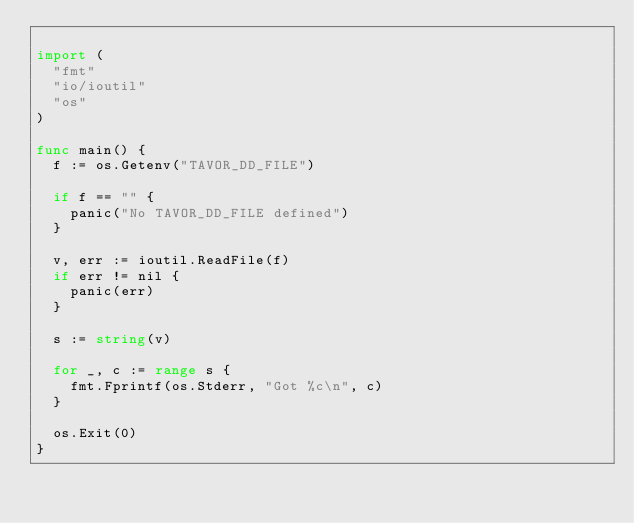<code> <loc_0><loc_0><loc_500><loc_500><_Go_>
import (
	"fmt"
	"io/ioutil"
	"os"
)

func main() {
	f := os.Getenv("TAVOR_DD_FILE")

	if f == "" {
		panic("No TAVOR_DD_FILE defined")
	}

	v, err := ioutil.ReadFile(f)
	if err != nil {
		panic(err)
	}

	s := string(v)

	for _, c := range s {
		fmt.Fprintf(os.Stderr, "Got %c\n", c)
	}

	os.Exit(0)
}
</code> 